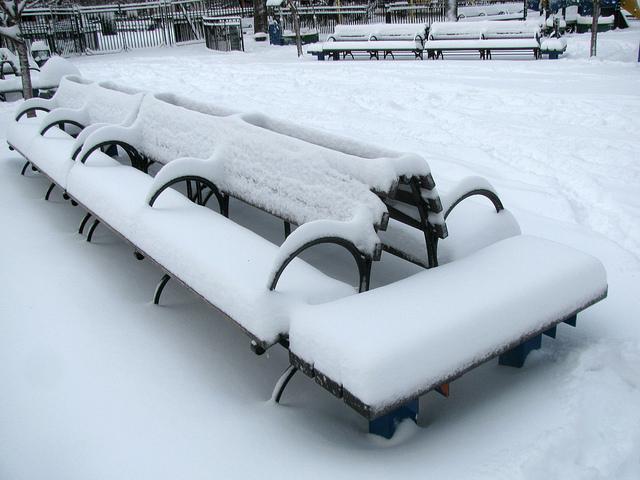What time of year is it?
Quick response, please. Winter. Is there a fence somewhere?
Give a very brief answer. Yes. Would someone get wet sitting on the bench?
Give a very brief answer. Yes. 